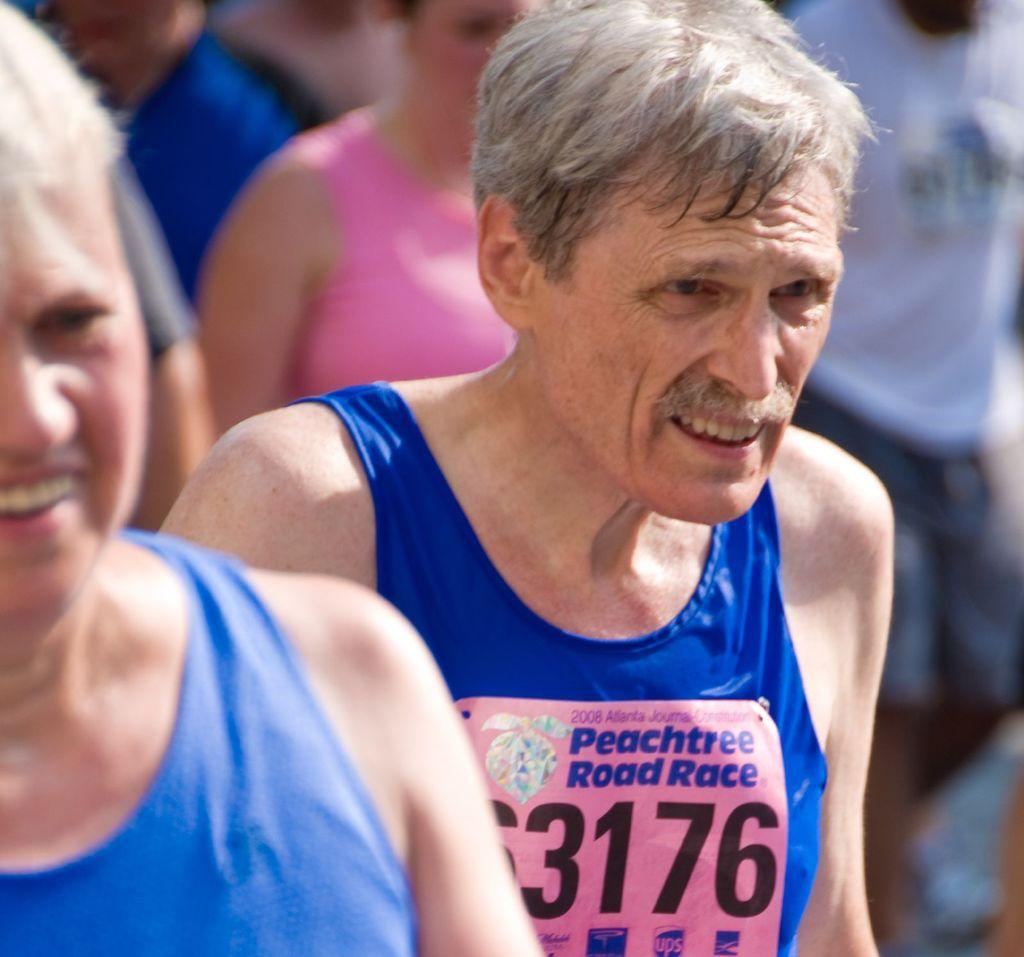What is on the right side of the image? There is a person on the right side of the image. What is the person on the right side wearing? The person on the right side is wearing a dress. What is unique about the dress? There is text written on the dress. What is happening on the left side of the image? There is a person on the left side of the image, and they are standing. How many eggs are visible in the image? There are no eggs present in the image. What type of loss is depicted in the image? There is no loss depicted in the image; it features two people, one wearing a dress with text and the other standing. 